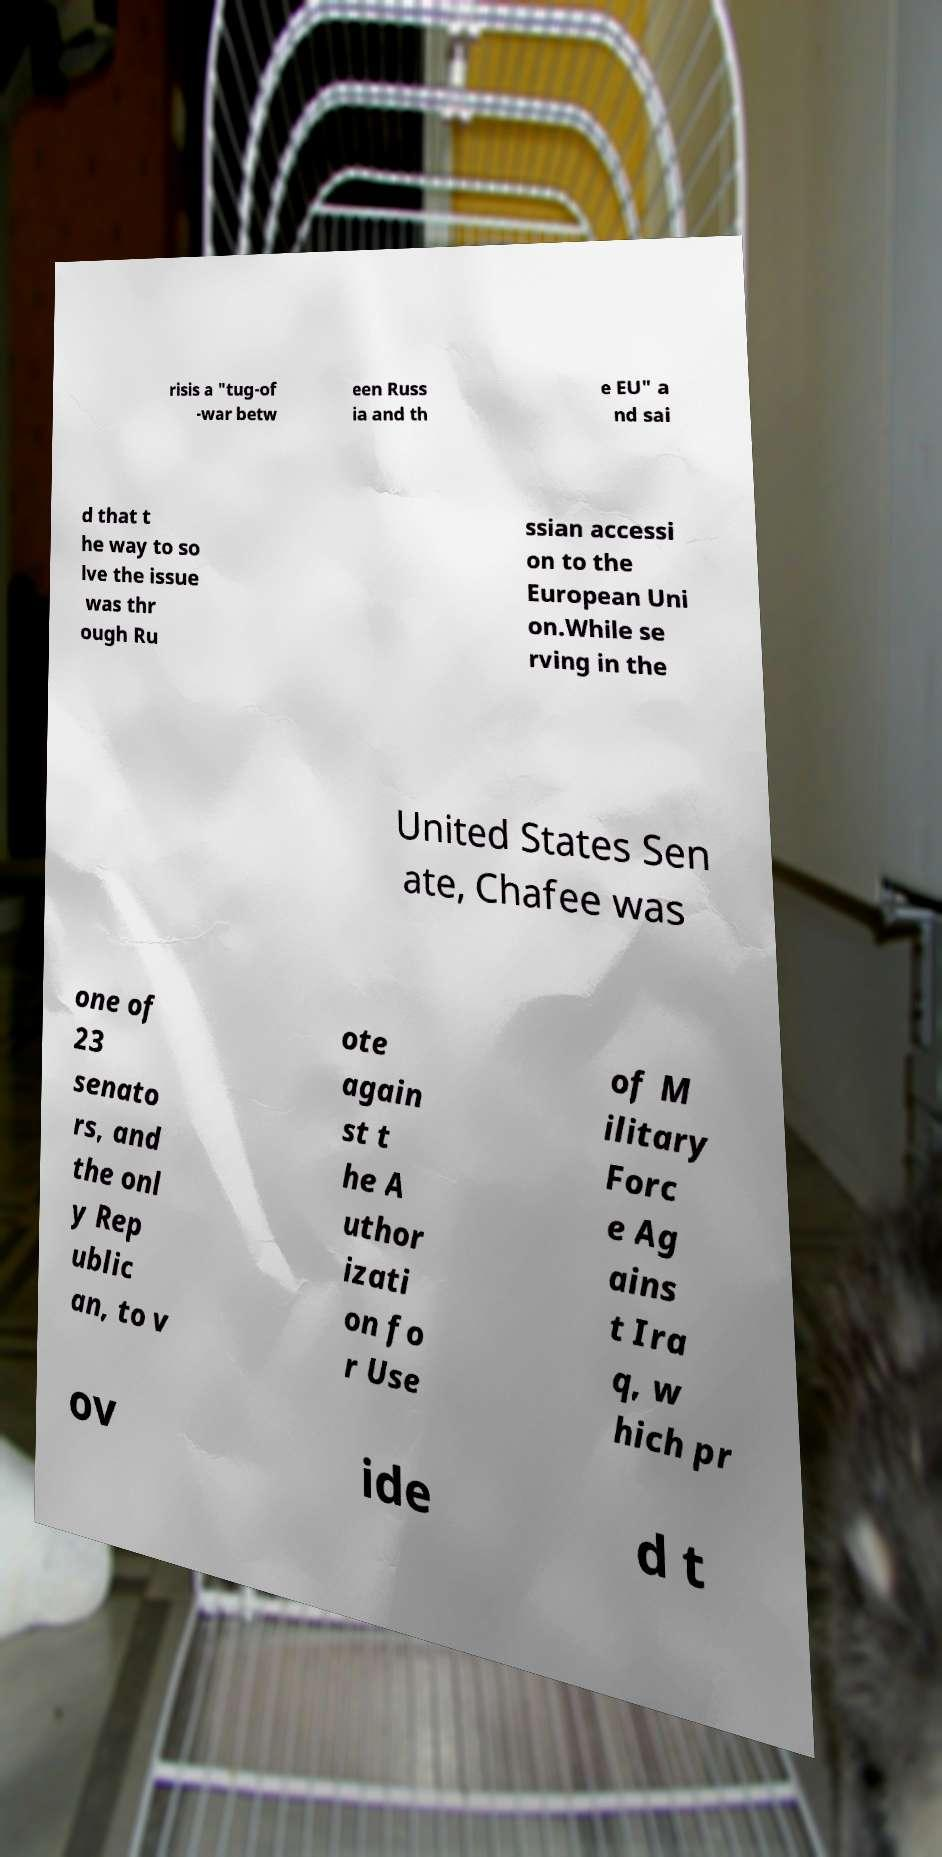I need the written content from this picture converted into text. Can you do that? risis a "tug-of -war betw een Russ ia and th e EU" a nd sai d that t he way to so lve the issue was thr ough Ru ssian accessi on to the European Uni on.While se rving in the United States Sen ate, Chafee was one of 23 senato rs, and the onl y Rep ublic an, to v ote again st t he A uthor izati on fo r Use of M ilitary Forc e Ag ains t Ira q, w hich pr ov ide d t 